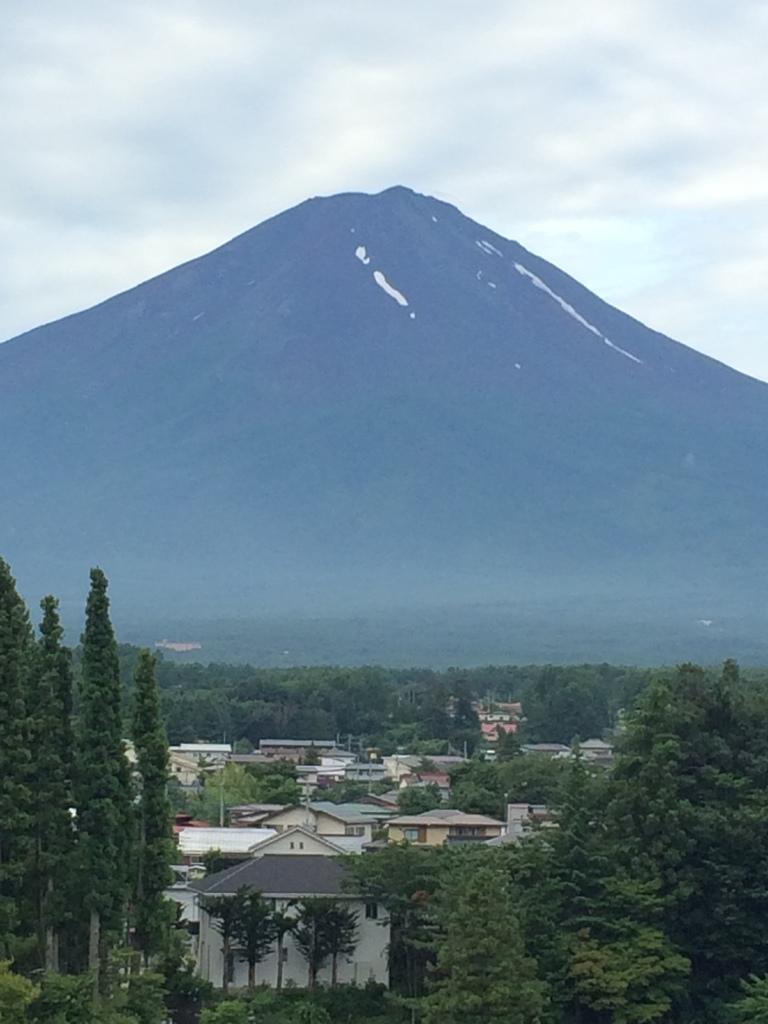Please provide a concise description of this image. This is a picture taken in a town. In the foreground of the picture there are trees and buildings. In the center of the background there is a mountain. Sky is cloudy. 